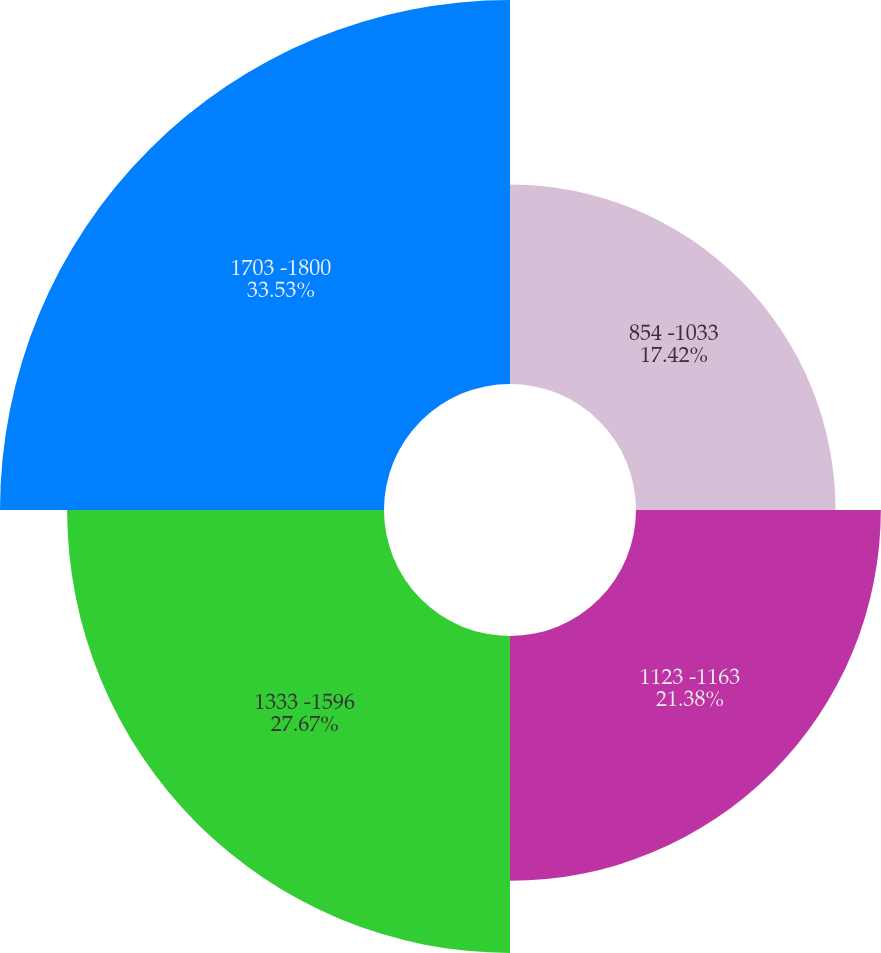<chart> <loc_0><loc_0><loc_500><loc_500><pie_chart><fcel>854 -1033<fcel>1123 -1163<fcel>1333 -1596<fcel>1703 -1800<nl><fcel>17.42%<fcel>21.38%<fcel>27.67%<fcel>33.53%<nl></chart> 